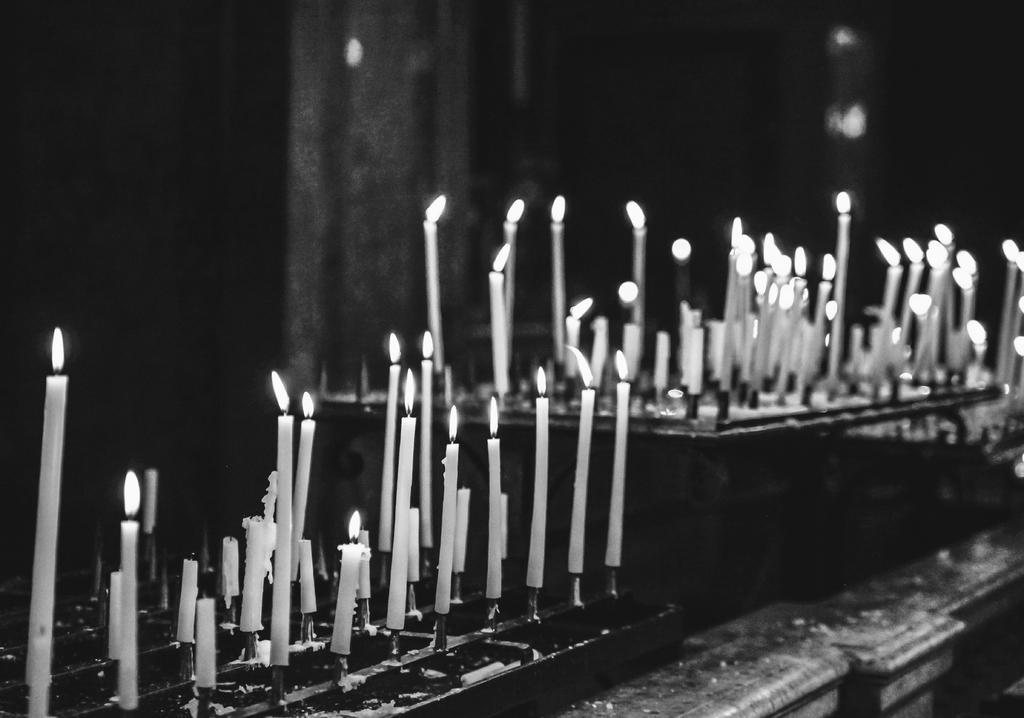Could you give a brief overview of what you see in this image? In the picture we can see a desk on it, we can see many candles with fire to it and beside also we can see another table with many candles and fire to it. 